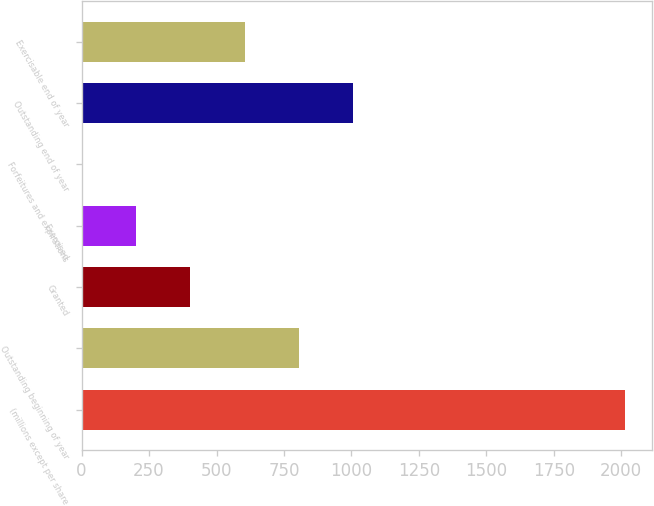<chart> <loc_0><loc_0><loc_500><loc_500><bar_chart><fcel>(millions except per share<fcel>Outstanding beginning of year<fcel>Granted<fcel>Exercised<fcel>Forfeitures and expirations<fcel>Outstanding end of year<fcel>Exercisable end of year<nl><fcel>2012<fcel>805.4<fcel>403.2<fcel>202.1<fcel>1<fcel>1006.5<fcel>604.3<nl></chart> 